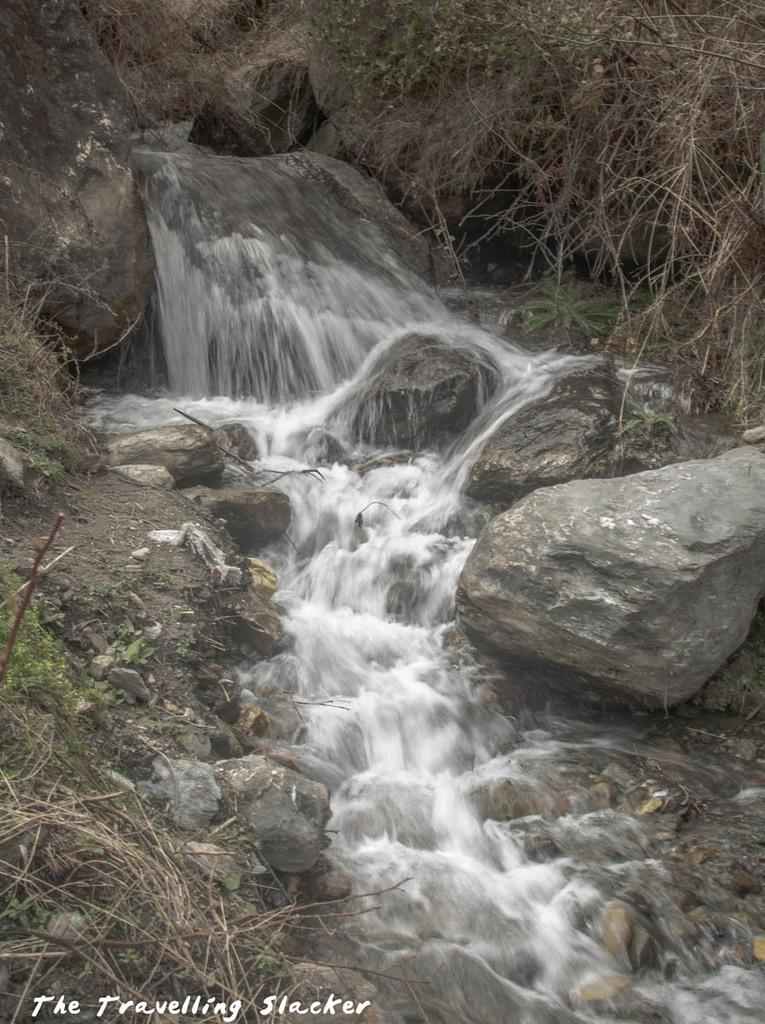What is the primary element visible in the image? There is water in the image. What other objects or features can be seen in the image? There are rocks and dry grass present in the image. What type of needle can be seen floating in the water in the image? There is no needle present in the image; it only contains water, rocks, and dry grass. 